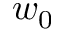<formula> <loc_0><loc_0><loc_500><loc_500>w _ { 0 }</formula> 